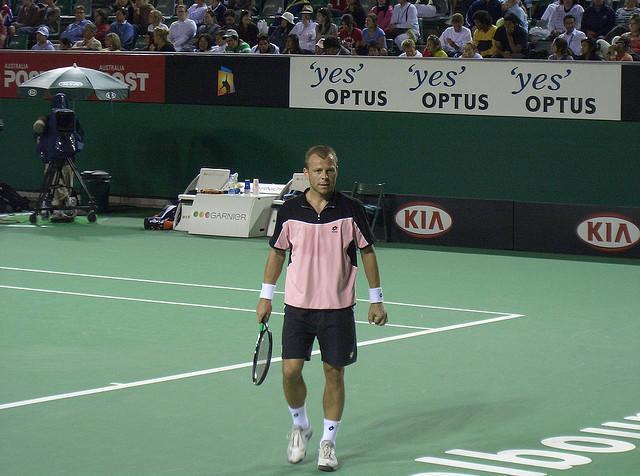How many people are there?
Give a very brief answer. 2. 